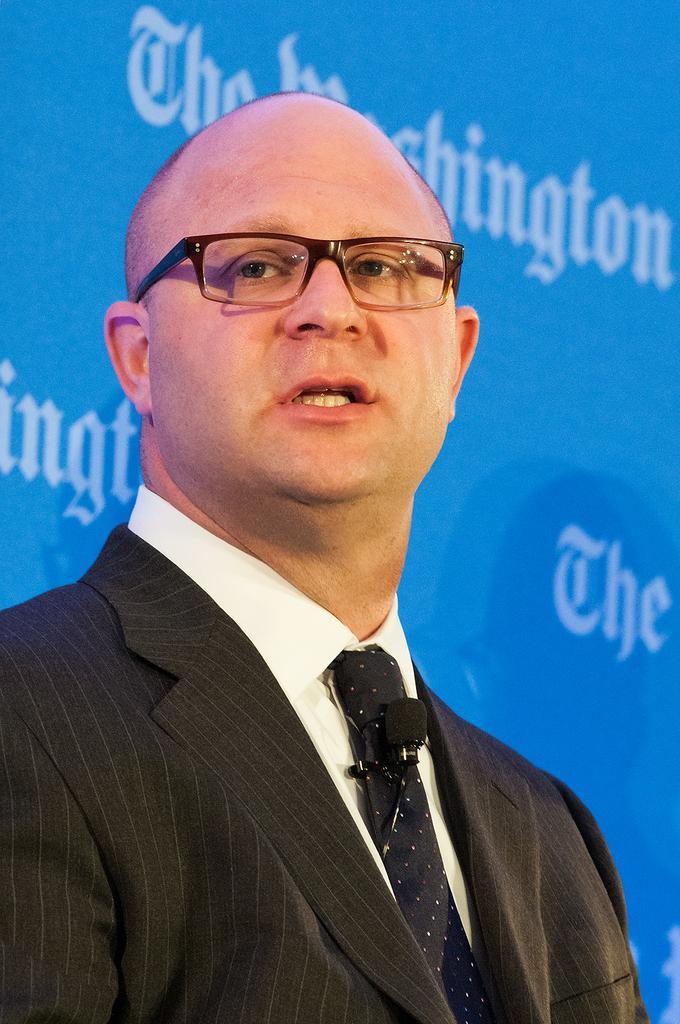How would you summarize this image in a sentence or two? In this picture we can see a man wore a blazer, tie, mic, spectacles and in the background we can see a banner. 